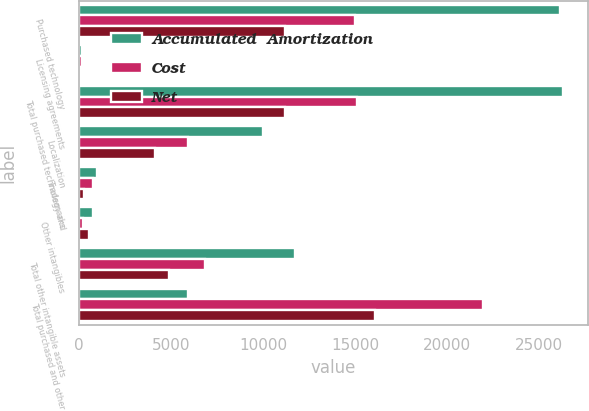Convert chart. <chart><loc_0><loc_0><loc_500><loc_500><stacked_bar_chart><ecel><fcel>Purchased technology<fcel>Licensing agreements<fcel>Total purchased technology and<fcel>Localization<fcel>Trademarks<fcel>Other intangibles<fcel>Total other intangible assets<fcel>Total purchased and other<nl><fcel>Accumulated  Amortization<fcel>26129<fcel>175<fcel>26304<fcel>10009<fcel>970<fcel>740<fcel>11719<fcel>5915<nl><fcel>Cost<fcel>14958<fcel>154<fcel>15112<fcel>5915<fcel>730<fcel>199<fcel>6844<fcel>21956<nl><fcel>Net<fcel>11171<fcel>21<fcel>11192<fcel>4094<fcel>240<fcel>541<fcel>4875<fcel>16067<nl></chart> 